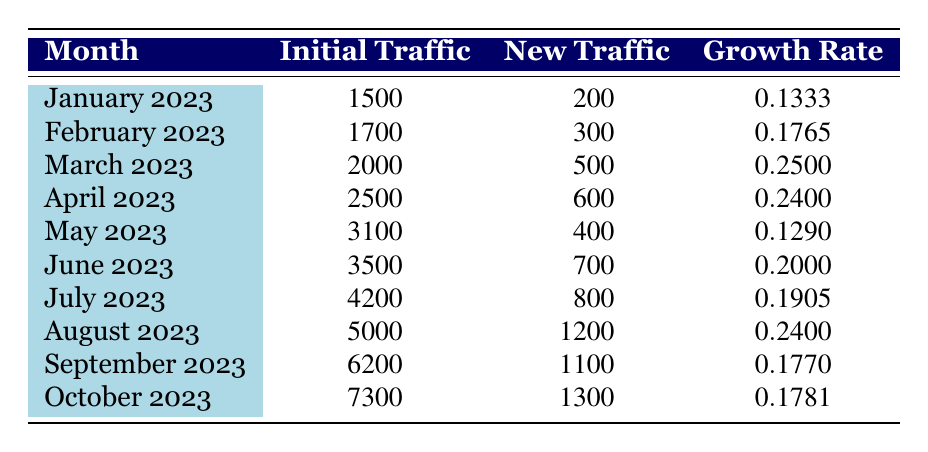What was the initial traffic for March 2023? The table shows that the value listed under "Initial Traffic" for March 2023 is 2000.
Answer: 2000 What is the growth rate for April 2023? The "Growth Rate" for April 2023 is directly provided in the table as 0.24.
Answer: 0.24 Which month had the highest growth rate and what was the rate? By examining the "Growth Rate" column, March 2023 has the highest growth rate of 0.25.
Answer: March 2023, 0.25 What is the total new traffic generated from January to April 2023? To find the total new traffic, add the "New Traffic" values for January (200), February (300), March (500), and April (600): 200 + 300 + 500 + 600 = 1600.
Answer: 1600 Did the website traffic grow in every month from January to October 2023? Reviewing the "New Traffic" column shows positive values for every month, which indicates growth in traffic each month.
Answer: Yes What is the average initial traffic from January to October 2023? To calculate the average, add the initial traffic for all months (1500 + 1700 + 2000 + 2500 + 3100 + 3500 + 4200 + 5000 + 6200 + 7300 = 29500) and divide by 10 (the number of months): 29500 / 10 = 2950.
Answer: 2950 How much new traffic was generated in August 2023 compared to July 2023? The new traffic for August 2023 is 1200, while for July 2023, it is 800. The difference is 1200 - 800 = 400.
Answer: 400 In which month did the growth rate drop below 0.20 after June 2023? Looking at the "Growth Rate" column, the rates for July (0.1905) and May (0.129) show values below 0.20, with July being the first instance.
Answer: July 2023 What was the change in growth rate from June to July 2023? The growth rate for June is 0.20 and for July is 0.1905. The change is calculated as 0.20 - 0.1905 = 0.0095, indicating a decrease.
Answer: 0.0095 